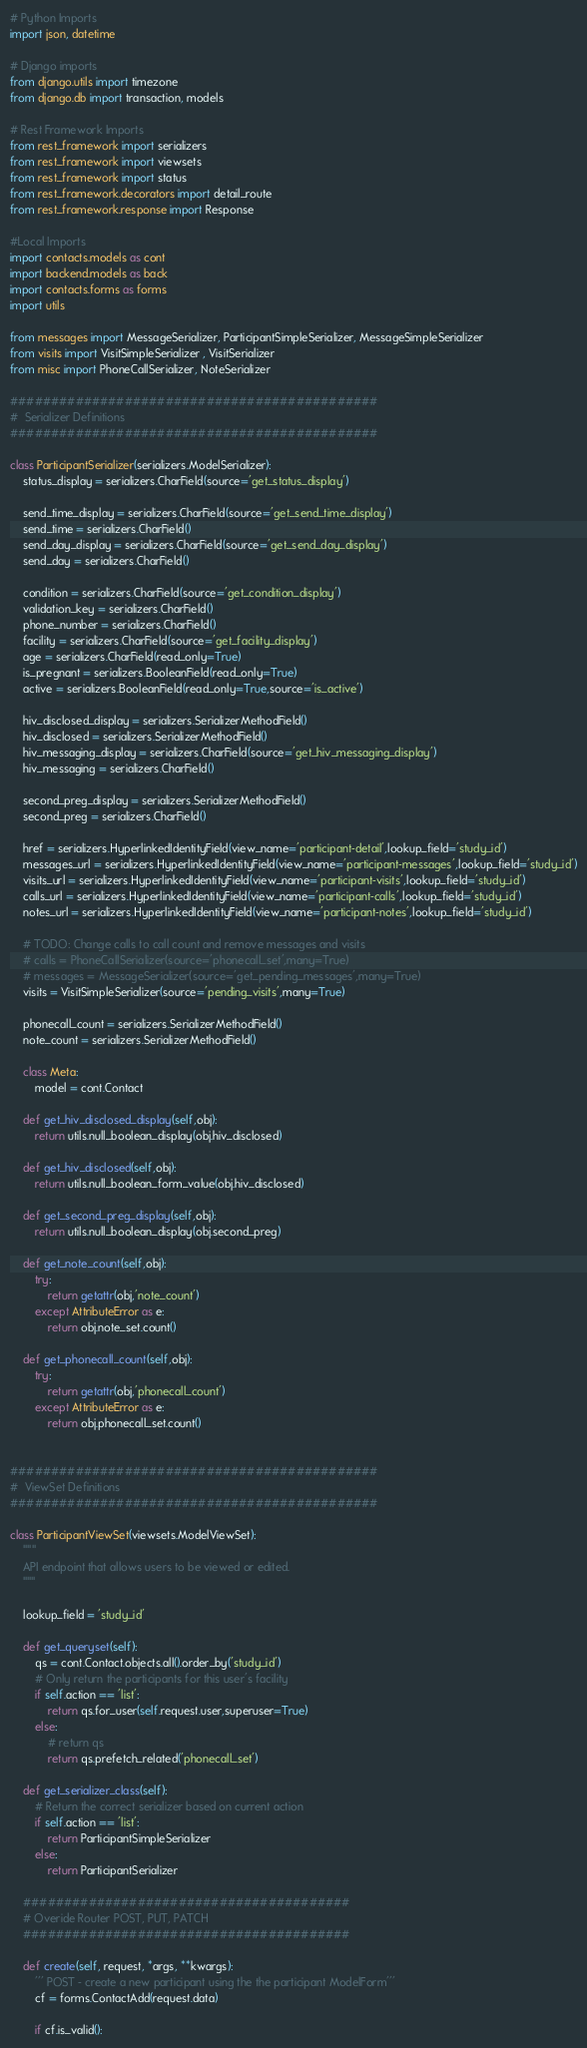Convert code to text. <code><loc_0><loc_0><loc_500><loc_500><_Python_># Python Imports
import json, datetime

# Django imports
from django.utils import timezone
from django.db import transaction, models

# Rest Framework Imports
from rest_framework import serializers
from rest_framework import viewsets
from rest_framework import status
from rest_framework.decorators import detail_route
from rest_framework.response import Response

#Local Imports
import contacts.models as cont
import backend.models as back
import contacts.forms as forms
import utils

from messages import MessageSerializer, ParticipantSimpleSerializer, MessageSimpleSerializer
from visits import VisitSimpleSerializer , VisitSerializer
from misc import PhoneCallSerializer, NoteSerializer

#############################################
#  Serializer Definitions
#############################################

class ParticipantSerializer(serializers.ModelSerializer):
    status_display = serializers.CharField(source='get_status_display')

    send_time_display = serializers.CharField(source='get_send_time_display')
    send_time = serializers.CharField()
    send_day_display = serializers.CharField(source='get_send_day_display')
    send_day = serializers.CharField()

    condition = serializers.CharField(source='get_condition_display')
    validation_key = serializers.CharField()
    phone_number = serializers.CharField()
    facility = serializers.CharField(source='get_facility_display')
    age = serializers.CharField(read_only=True)
    is_pregnant = serializers.BooleanField(read_only=True)
    active = serializers.BooleanField(read_only=True,source='is_active')

    hiv_disclosed_display = serializers.SerializerMethodField()
    hiv_disclosed = serializers.SerializerMethodField()
    hiv_messaging_display = serializers.CharField(source='get_hiv_messaging_display')
    hiv_messaging = serializers.CharField()

    second_preg_display = serializers.SerializerMethodField()
    second_preg = serializers.CharField()

    href = serializers.HyperlinkedIdentityField(view_name='participant-detail',lookup_field='study_id')
    messages_url = serializers.HyperlinkedIdentityField(view_name='participant-messages',lookup_field='study_id')
    visits_url = serializers.HyperlinkedIdentityField(view_name='participant-visits',lookup_field='study_id')
    calls_url = serializers.HyperlinkedIdentityField(view_name='participant-calls',lookup_field='study_id')
    notes_url = serializers.HyperlinkedIdentityField(view_name='participant-notes',lookup_field='study_id')

    # TODO: Change calls to call count and remove messages and visits
    # calls = PhoneCallSerializer(source='phonecall_set',many=True)
    # messages = MessageSerializer(source='get_pending_messages',many=True)
    visits = VisitSimpleSerializer(source='pending_visits',many=True)

    phonecall_count = serializers.SerializerMethodField()
    note_count = serializers.SerializerMethodField()

    class Meta:
        model = cont.Contact

    def get_hiv_disclosed_display(self,obj):
        return utils.null_boolean_display(obj.hiv_disclosed)

    def get_hiv_disclosed(self,obj):
        return utils.null_boolean_form_value(obj.hiv_disclosed)

    def get_second_preg_display(self,obj):
        return utils.null_boolean_display(obj.second_preg)

    def get_note_count(self,obj):
        try:
            return getattr(obj,'note_count')
        except AttributeError as e:
            return obj.note_set.count()

    def get_phonecall_count(self,obj):
        try:
            return getattr(obj,'phonecall_count')
        except AttributeError as e:
            return obj.phonecall_set.count()


#############################################
#  ViewSet Definitions
#############################################

class ParticipantViewSet(viewsets.ModelViewSet):
    """
    API endpoint that allows users to be viewed or edited.
    """

    lookup_field = 'study_id'

    def get_queryset(self):
        qs = cont.Contact.objects.all().order_by('study_id')
        # Only return the participants for this user's facility
        if self.action == 'list':
            return qs.for_user(self.request.user,superuser=True)
        else:
            # return qs
            return qs.prefetch_related('phonecall_set')

    def get_serializer_class(self):
        # Return the correct serializer based on current action
        if self.action == 'list':
            return ParticipantSimpleSerializer
        else:
            return ParticipantSerializer

    ########################################
    # Overide Router POST, PUT, PATCH
    ########################################

    def create(self, request, *args, **kwargs):
        ''' POST - create a new participant using the the participant ModelForm'''
        cf = forms.ContactAdd(request.data)

        if cf.is_valid():</code> 